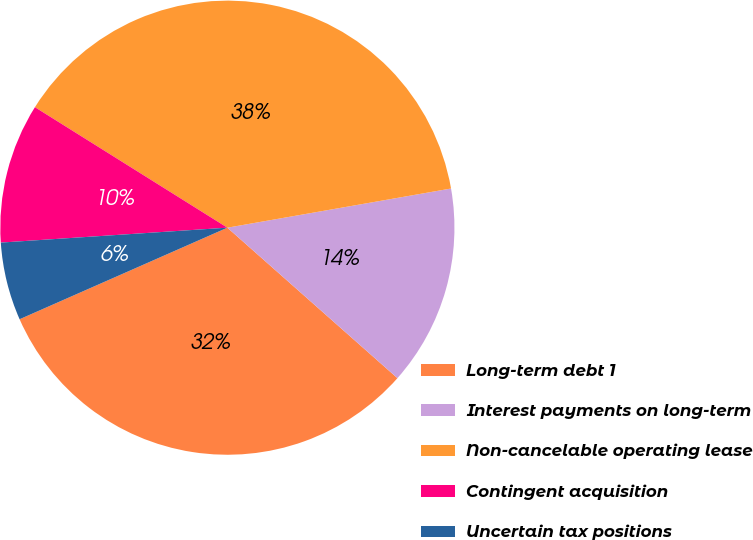Convert chart. <chart><loc_0><loc_0><loc_500><loc_500><pie_chart><fcel>Long-term debt 1<fcel>Interest payments on long-term<fcel>Non-cancelable operating lease<fcel>Contingent acquisition<fcel>Uncertain tax positions<nl><fcel>31.87%<fcel>14.29%<fcel>38.34%<fcel>9.95%<fcel>5.56%<nl></chart> 